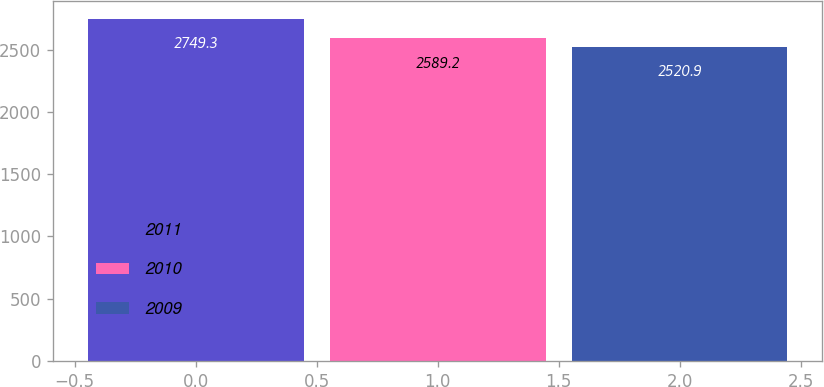Convert chart to OTSL. <chart><loc_0><loc_0><loc_500><loc_500><bar_chart><fcel>2011<fcel>2010<fcel>2009<nl><fcel>2749.3<fcel>2589.2<fcel>2520.9<nl></chart> 